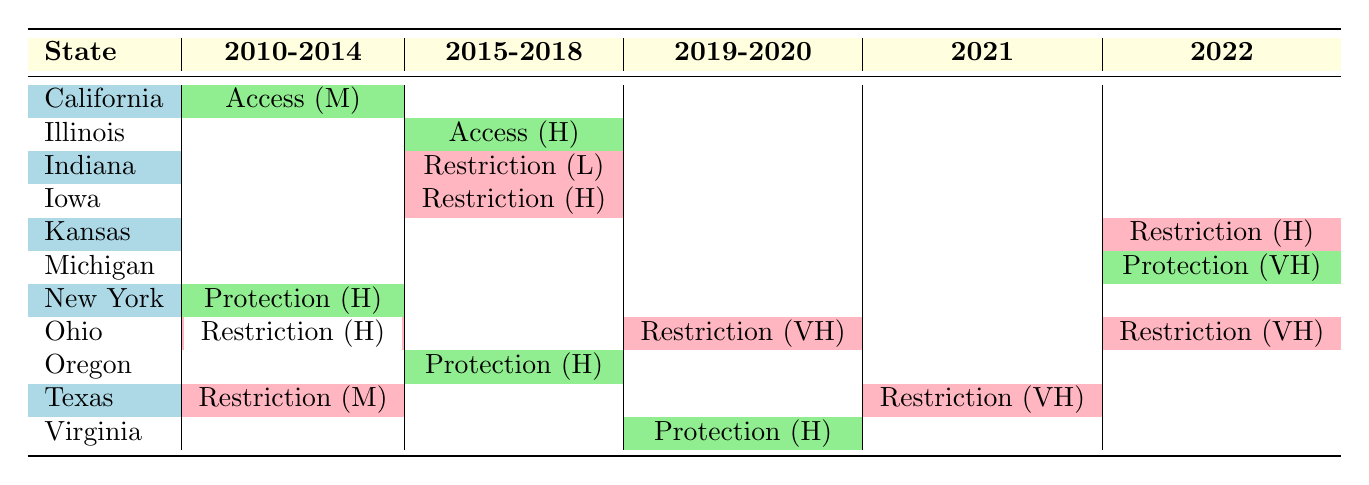What types of legislation were passed in New York between 2010 and 2014? The table shows that in 2011, New York passed the Reproductive Health Act, which is categorized as Protection. Therefore, the type of legislation passed in New York during that time is Protection.
Answer: Protection Which state had the highest impact legislation in 2019? Looking at the 2019 row, Ohio has the 6-Week Abortion Ban with an impact classified as Very High. Therefore, Ohio had the highest impact legislation in 2019.
Answer: Ohio What was the total number of Protection legislations enacted from 2010 to 2022? The table indicates that Protection legislations were passed in New York (2011), Illinois (2017), Virginia (2020), and Michigan (2022). This totals to four Protection legislations.
Answer: 4 Did Indiana pass any access-related legislation during the period? The table shows that Indiana introduced the Fetal Remains Burial legislation in 2016, which is categorized as Restriction. Therefore, Indiana did not pass any Access-related legislation during this time.
Answer: No How many states had medium impact restrictions from 2010 to 2014? From the table, California had a medium impact Access (2013), Indiana had a low impact Restriction (2016), and Texas had a medium impact Restriction (2012). In 2010-2014, only Texas had a medium impact Restriction. So, only one state falls under this category.
Answer: 1 Which state had the most restrictions in 2022? In the year 2022, Ohio's Trigger Law had a Very High impact, and Kansas rejected the Value Them Both Amendment with High impact. Consequently, Ohio had the most restrictions in 2022.
Answer: Ohio What is the difference in the number of Protection legislations between 2015-2018 compared to 2010-2014? The Protection legislation passed in 2010-2014 was one (New York 2011), while in 2015-2018, Protection legislation was passed in Oregon (2015). Hence, there is no difference as both time frames had only one Protection legislation.
Answer: 0 In which year did Ohio implement the most impactful restriction, and what was it? From the table, Ohio implemented the 6-Week Abortion Ban in 2019, categorized as Restriction with Very High impact, making it the most impactful restriction in that year.
Answer: 2019, 6-Week Abortion Ban How many states experienced blocked legislation during the time period? The table lists blocked legislation in Indiana (2016) and Iowa (2018), indicating that there were two states that faced blocked legislation.
Answer: 2 